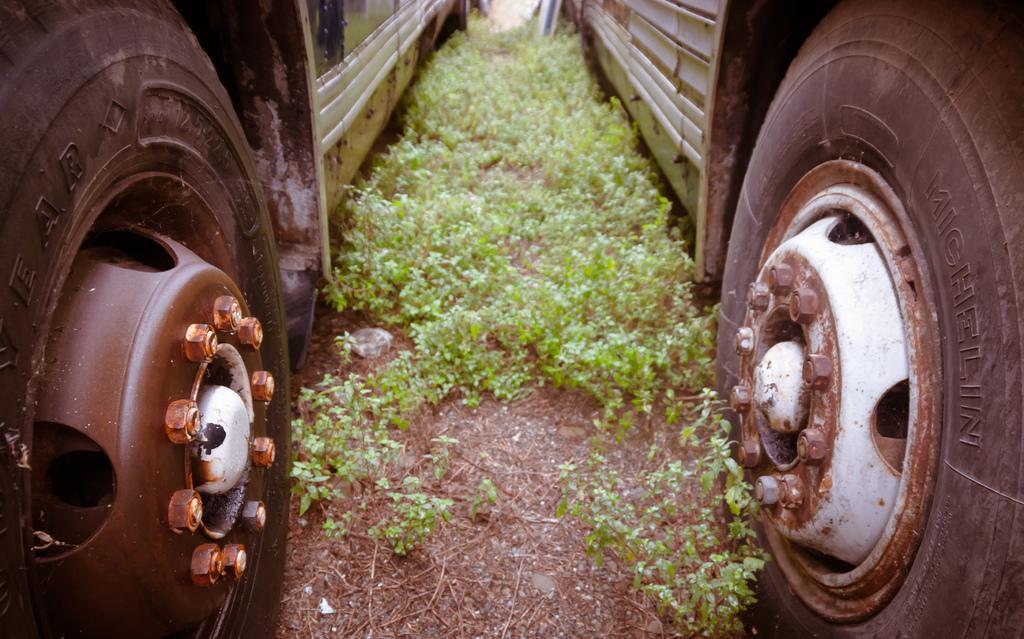In one or two sentences, can you explain what this image depicts? In this image there are two vehicles on a land, in the middle there are small plants. 